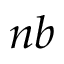<formula> <loc_0><loc_0><loc_500><loc_500>n b</formula> 